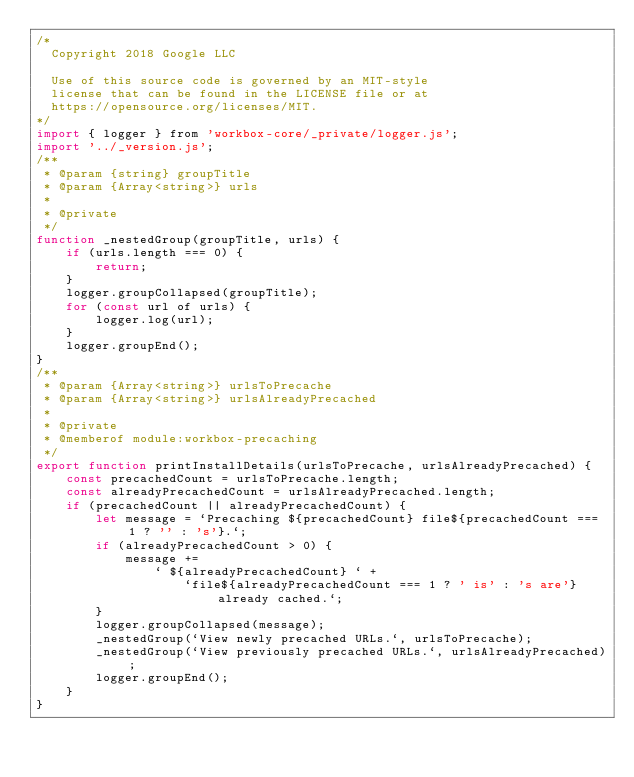Convert code to text. <code><loc_0><loc_0><loc_500><loc_500><_JavaScript_>/*
  Copyright 2018 Google LLC

  Use of this source code is governed by an MIT-style
  license that can be found in the LICENSE file or at
  https://opensource.org/licenses/MIT.
*/
import { logger } from 'workbox-core/_private/logger.js';
import '../_version.js';
/**
 * @param {string} groupTitle
 * @param {Array<string>} urls
 *
 * @private
 */
function _nestedGroup(groupTitle, urls) {
    if (urls.length === 0) {
        return;
    }
    logger.groupCollapsed(groupTitle);
    for (const url of urls) {
        logger.log(url);
    }
    logger.groupEnd();
}
/**
 * @param {Array<string>} urlsToPrecache
 * @param {Array<string>} urlsAlreadyPrecached
 *
 * @private
 * @memberof module:workbox-precaching
 */
export function printInstallDetails(urlsToPrecache, urlsAlreadyPrecached) {
    const precachedCount = urlsToPrecache.length;
    const alreadyPrecachedCount = urlsAlreadyPrecached.length;
    if (precachedCount || alreadyPrecachedCount) {
        let message = `Precaching ${precachedCount} file${precachedCount === 1 ? '' : 's'}.`;
        if (alreadyPrecachedCount > 0) {
            message +=
                ` ${alreadyPrecachedCount} ` +
                    `file${alreadyPrecachedCount === 1 ? ' is' : 's are'} already cached.`;
        }
        logger.groupCollapsed(message);
        _nestedGroup(`View newly precached URLs.`, urlsToPrecache);
        _nestedGroup(`View previously precached URLs.`, urlsAlreadyPrecached);
        logger.groupEnd();
    }
}
</code> 